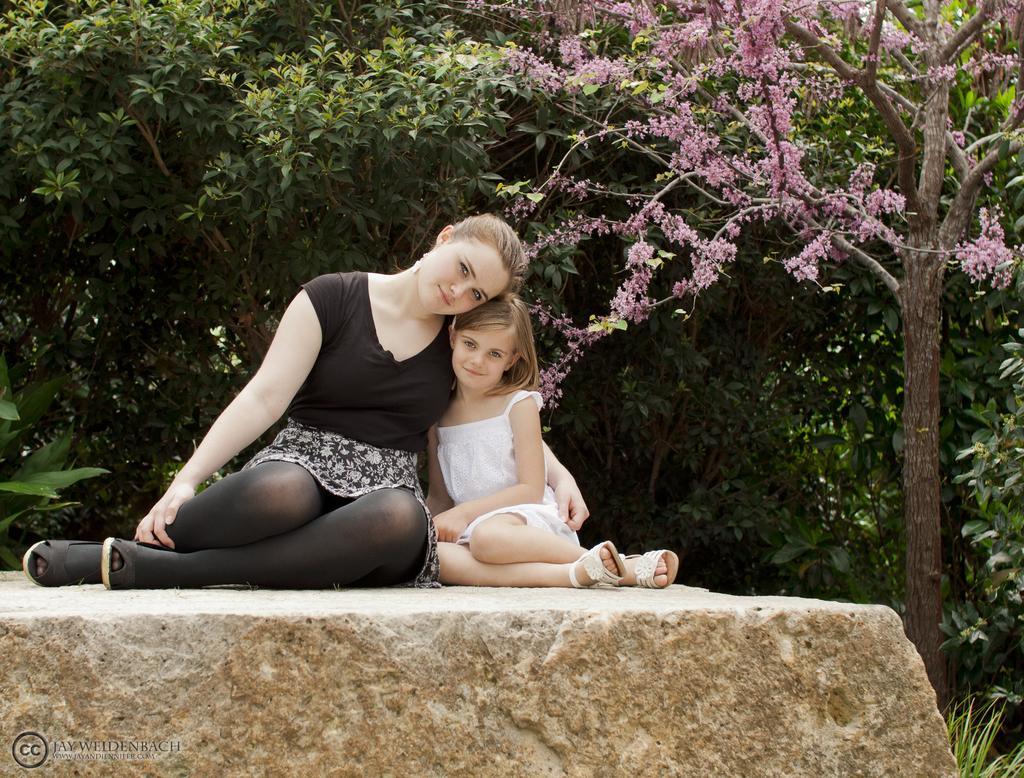Describe this image in one or two sentences. In the background we can see the trees. In this picture we can see plants, flowers and branches. We can see a woman and a girl sitting on the stone. They both are smiling and giving a pose. 